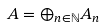<formula> <loc_0><loc_0><loc_500><loc_500>A = \oplus _ { n \in \mathbb { N } } A _ { n }</formula> 